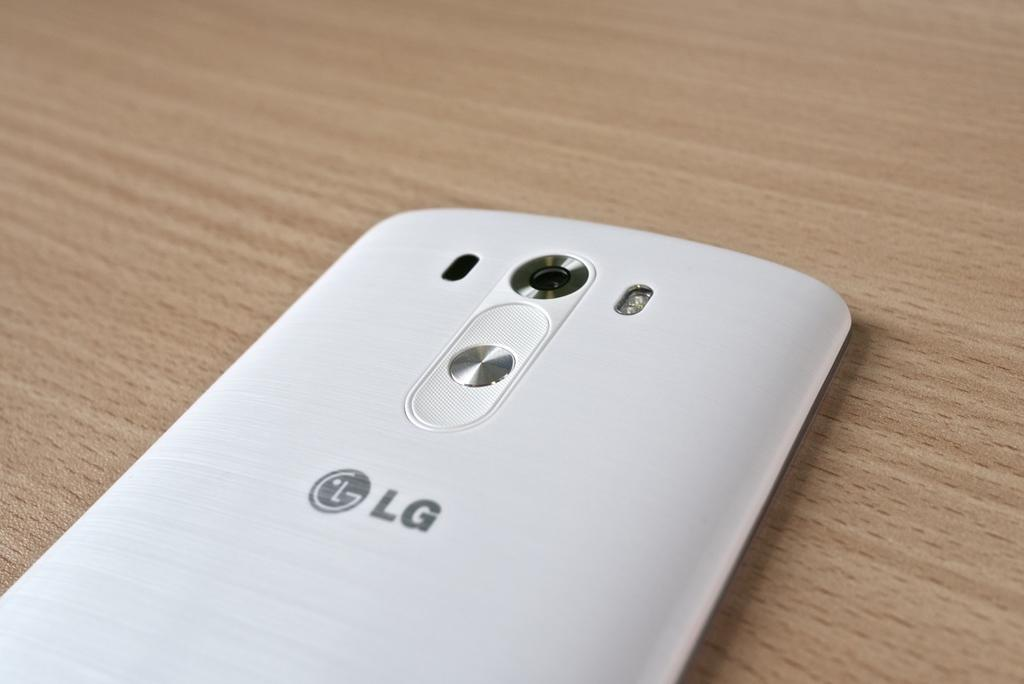<image>
Describe the image concisely. The white LG phone is siting on the table face down. 